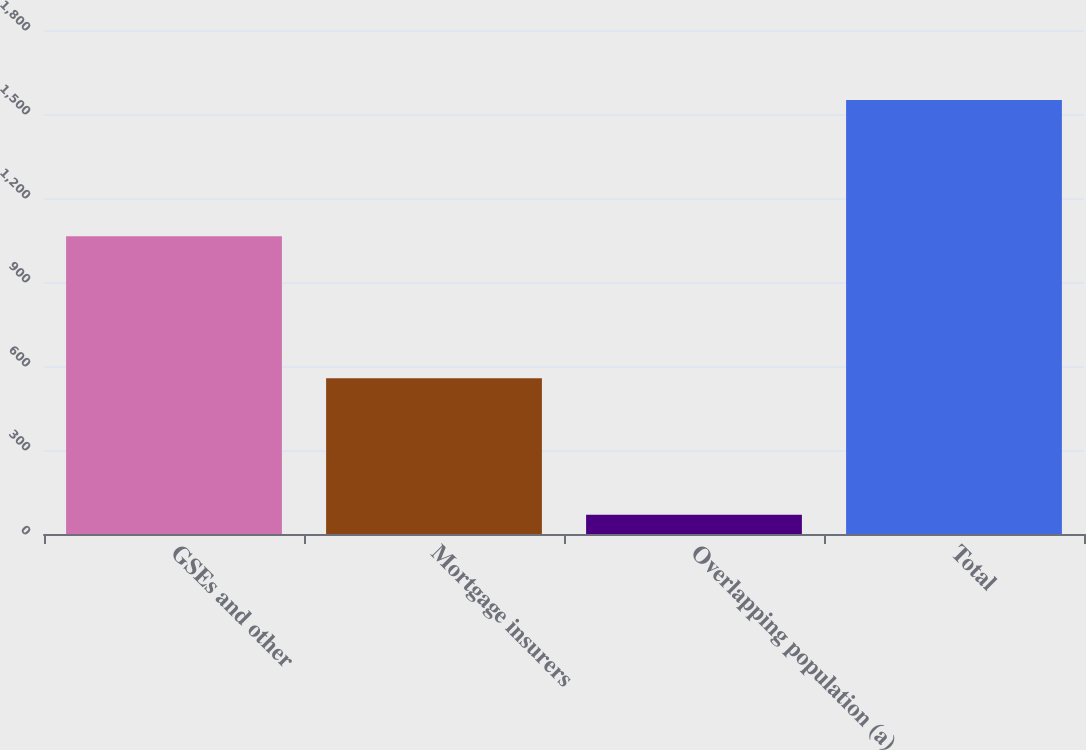Convert chart to OTSL. <chart><loc_0><loc_0><loc_500><loc_500><bar_chart><fcel>GSEs and other<fcel>Mortgage insurers<fcel>Overlapping population (a)<fcel>Total<nl><fcel>1063<fcel>556<fcel>69<fcel>1550<nl></chart> 